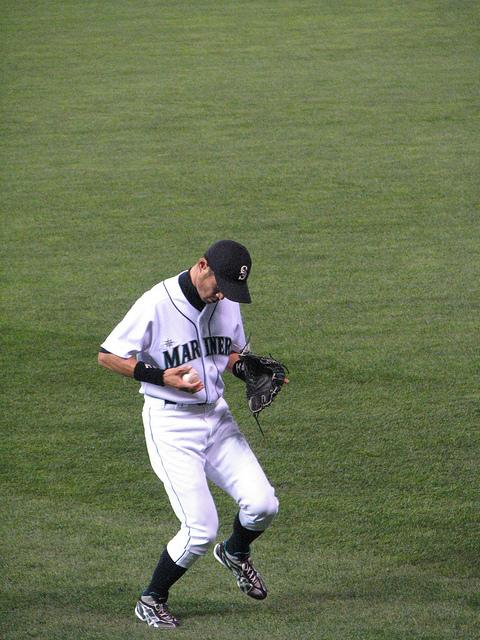Why is the man wearing a glove?

Choices:
A) warmth
B) to catch
C) fashion
D) health to catch 